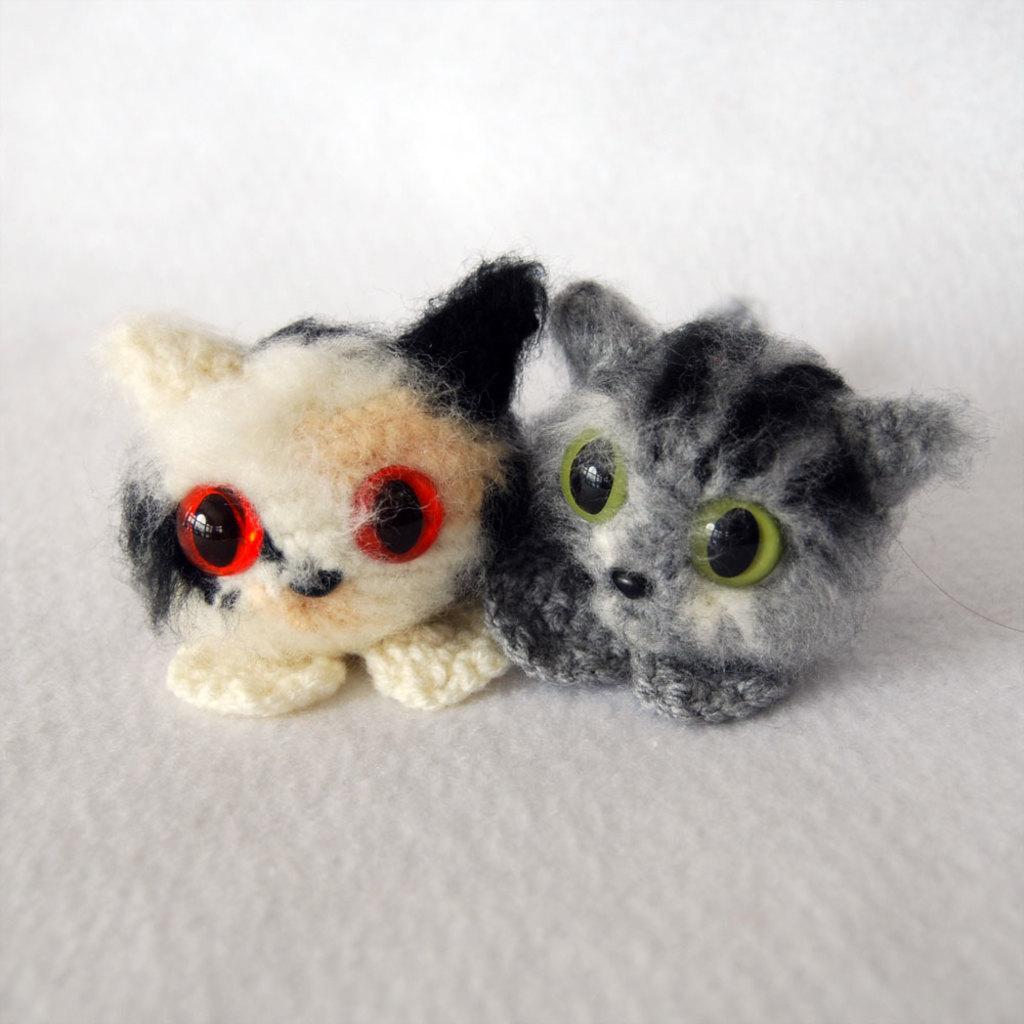Please provide a concise description of this image. In this image there are two toys, the background of the image is white in color. 